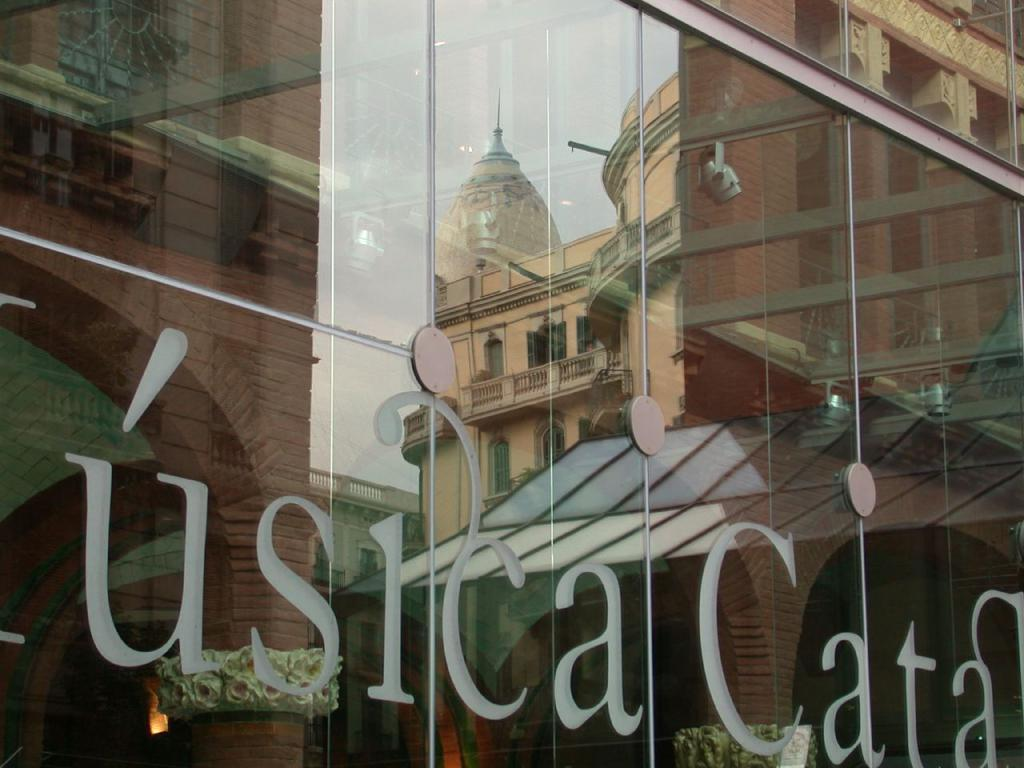What is the main subject of the image? The main subject of the image is a reflection of a building. Where is the reflection located in the image? The reflection of the building is in the center of the image. Is there any text present in the image? Yes, there is some text at the bottom of the image. What type of cabbage is being harvested by the family in the image? There is no family or cabbage present in the image; it features a reflection of a building and some text. How does the impulse affect the image? There is no mention of an impulse in the image, as it only contains a reflection of a building and some text. 